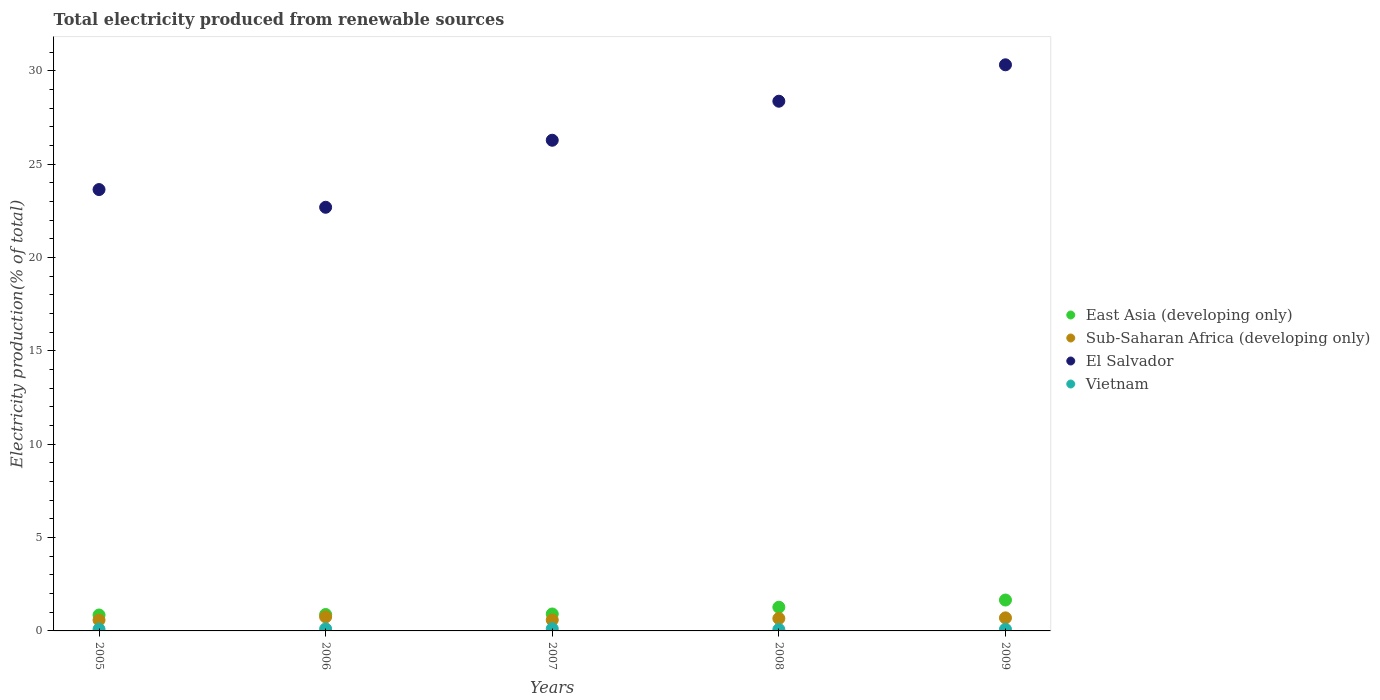How many different coloured dotlines are there?
Ensure brevity in your answer.  4. Is the number of dotlines equal to the number of legend labels?
Offer a terse response. Yes. What is the total electricity produced in East Asia (developing only) in 2008?
Provide a succinct answer. 1.27. Across all years, what is the maximum total electricity produced in East Asia (developing only)?
Make the answer very short. 1.65. Across all years, what is the minimum total electricity produced in Sub-Saharan Africa (developing only)?
Make the answer very short. 0.58. In which year was the total electricity produced in Sub-Saharan Africa (developing only) maximum?
Provide a short and direct response. 2006. What is the total total electricity produced in East Asia (developing only) in the graph?
Offer a terse response. 5.56. What is the difference between the total electricity produced in Sub-Saharan Africa (developing only) in 2007 and that in 2008?
Your response must be concise. -0.08. What is the difference between the total electricity produced in El Salvador in 2006 and the total electricity produced in East Asia (developing only) in 2007?
Your answer should be compact. 21.78. What is the average total electricity produced in Sub-Saharan Africa (developing only) per year?
Give a very brief answer. 0.66. In the year 2005, what is the difference between the total electricity produced in East Asia (developing only) and total electricity produced in Sub-Saharan Africa (developing only)?
Give a very brief answer. 0.27. What is the ratio of the total electricity produced in El Salvador in 2005 to that in 2009?
Make the answer very short. 0.78. Is the total electricity produced in Sub-Saharan Africa (developing only) in 2005 less than that in 2008?
Offer a terse response. Yes. What is the difference between the highest and the second highest total electricity produced in Sub-Saharan Africa (developing only)?
Your answer should be compact. 0.05. What is the difference between the highest and the lowest total electricity produced in Vietnam?
Provide a short and direct response. 0.04. Is it the case that in every year, the sum of the total electricity produced in East Asia (developing only) and total electricity produced in Sub-Saharan Africa (developing only)  is greater than the sum of total electricity produced in El Salvador and total electricity produced in Vietnam?
Provide a succinct answer. Yes. Is it the case that in every year, the sum of the total electricity produced in Sub-Saharan Africa (developing only) and total electricity produced in East Asia (developing only)  is greater than the total electricity produced in Vietnam?
Your answer should be compact. Yes. Does the total electricity produced in El Salvador monotonically increase over the years?
Provide a short and direct response. No. Is the total electricity produced in Vietnam strictly greater than the total electricity produced in El Salvador over the years?
Provide a short and direct response. No. Is the total electricity produced in East Asia (developing only) strictly less than the total electricity produced in Sub-Saharan Africa (developing only) over the years?
Give a very brief answer. No. How many dotlines are there?
Ensure brevity in your answer.  4. What is the difference between two consecutive major ticks on the Y-axis?
Your response must be concise. 5. Are the values on the major ticks of Y-axis written in scientific E-notation?
Keep it short and to the point. No. Does the graph contain grids?
Your response must be concise. No. What is the title of the graph?
Ensure brevity in your answer.  Total electricity produced from renewable sources. Does "High income" appear as one of the legend labels in the graph?
Your answer should be compact. No. What is the label or title of the Y-axis?
Provide a succinct answer. Electricity production(% of total). What is the Electricity production(% of total) in East Asia (developing only) in 2005?
Make the answer very short. 0.85. What is the Electricity production(% of total) in Sub-Saharan Africa (developing only) in 2005?
Ensure brevity in your answer.  0.58. What is the Electricity production(% of total) in El Salvador in 2005?
Your response must be concise. 23.64. What is the Electricity production(% of total) of Vietnam in 2005?
Give a very brief answer. 0.09. What is the Electricity production(% of total) in East Asia (developing only) in 2006?
Keep it short and to the point. 0.88. What is the Electricity production(% of total) of Sub-Saharan Africa (developing only) in 2006?
Your response must be concise. 0.75. What is the Electricity production(% of total) of El Salvador in 2006?
Provide a short and direct response. 22.69. What is the Electricity production(% of total) in Vietnam in 2006?
Make the answer very short. 0.11. What is the Electricity production(% of total) in East Asia (developing only) in 2007?
Make the answer very short. 0.91. What is the Electricity production(% of total) in Sub-Saharan Africa (developing only) in 2007?
Provide a short and direct response. 0.59. What is the Electricity production(% of total) in El Salvador in 2007?
Offer a very short reply. 26.28. What is the Electricity production(% of total) in Vietnam in 2007?
Offer a very short reply. 0.12. What is the Electricity production(% of total) in East Asia (developing only) in 2008?
Your answer should be compact. 1.27. What is the Electricity production(% of total) of Sub-Saharan Africa (developing only) in 2008?
Your answer should be compact. 0.67. What is the Electricity production(% of total) of El Salvador in 2008?
Make the answer very short. 28.37. What is the Electricity production(% of total) of Vietnam in 2008?
Ensure brevity in your answer.  0.08. What is the Electricity production(% of total) of East Asia (developing only) in 2009?
Offer a terse response. 1.65. What is the Electricity production(% of total) of Sub-Saharan Africa (developing only) in 2009?
Make the answer very short. 0.7. What is the Electricity production(% of total) of El Salvador in 2009?
Your answer should be compact. 30.32. What is the Electricity production(% of total) of Vietnam in 2009?
Offer a very short reply. 0.09. Across all years, what is the maximum Electricity production(% of total) of East Asia (developing only)?
Offer a terse response. 1.65. Across all years, what is the maximum Electricity production(% of total) of Sub-Saharan Africa (developing only)?
Keep it short and to the point. 0.75. Across all years, what is the maximum Electricity production(% of total) of El Salvador?
Make the answer very short. 30.32. Across all years, what is the maximum Electricity production(% of total) in Vietnam?
Offer a very short reply. 0.12. Across all years, what is the minimum Electricity production(% of total) of East Asia (developing only)?
Your answer should be compact. 0.85. Across all years, what is the minimum Electricity production(% of total) in Sub-Saharan Africa (developing only)?
Keep it short and to the point. 0.58. Across all years, what is the minimum Electricity production(% of total) in El Salvador?
Your answer should be compact. 22.69. Across all years, what is the minimum Electricity production(% of total) in Vietnam?
Offer a terse response. 0.08. What is the total Electricity production(% of total) of East Asia (developing only) in the graph?
Offer a very short reply. 5.56. What is the total Electricity production(% of total) of Sub-Saharan Africa (developing only) in the graph?
Offer a very short reply. 3.29. What is the total Electricity production(% of total) in El Salvador in the graph?
Provide a short and direct response. 131.29. What is the total Electricity production(% of total) of Vietnam in the graph?
Provide a succinct answer. 0.48. What is the difference between the Electricity production(% of total) in East Asia (developing only) in 2005 and that in 2006?
Keep it short and to the point. -0.03. What is the difference between the Electricity production(% of total) of Sub-Saharan Africa (developing only) in 2005 and that in 2006?
Offer a terse response. -0.17. What is the difference between the Electricity production(% of total) of El Salvador in 2005 and that in 2006?
Ensure brevity in your answer.  0.95. What is the difference between the Electricity production(% of total) in Vietnam in 2005 and that in 2006?
Your response must be concise. -0.01. What is the difference between the Electricity production(% of total) in East Asia (developing only) in 2005 and that in 2007?
Make the answer very short. -0.06. What is the difference between the Electricity production(% of total) of Sub-Saharan Africa (developing only) in 2005 and that in 2007?
Your response must be concise. -0.01. What is the difference between the Electricity production(% of total) in El Salvador in 2005 and that in 2007?
Offer a very short reply. -2.64. What is the difference between the Electricity production(% of total) in Vietnam in 2005 and that in 2007?
Your response must be concise. -0.02. What is the difference between the Electricity production(% of total) of East Asia (developing only) in 2005 and that in 2008?
Ensure brevity in your answer.  -0.42. What is the difference between the Electricity production(% of total) in Sub-Saharan Africa (developing only) in 2005 and that in 2008?
Give a very brief answer. -0.09. What is the difference between the Electricity production(% of total) in El Salvador in 2005 and that in 2008?
Give a very brief answer. -4.73. What is the difference between the Electricity production(% of total) in Vietnam in 2005 and that in 2008?
Provide a succinct answer. 0.02. What is the difference between the Electricity production(% of total) in East Asia (developing only) in 2005 and that in 2009?
Give a very brief answer. -0.8. What is the difference between the Electricity production(% of total) in Sub-Saharan Africa (developing only) in 2005 and that in 2009?
Keep it short and to the point. -0.12. What is the difference between the Electricity production(% of total) in El Salvador in 2005 and that in 2009?
Offer a very short reply. -6.68. What is the difference between the Electricity production(% of total) of Vietnam in 2005 and that in 2009?
Keep it short and to the point. 0.01. What is the difference between the Electricity production(% of total) of East Asia (developing only) in 2006 and that in 2007?
Offer a very short reply. -0.03. What is the difference between the Electricity production(% of total) in Sub-Saharan Africa (developing only) in 2006 and that in 2007?
Offer a very short reply. 0.16. What is the difference between the Electricity production(% of total) of El Salvador in 2006 and that in 2007?
Give a very brief answer. -3.59. What is the difference between the Electricity production(% of total) in Vietnam in 2006 and that in 2007?
Ensure brevity in your answer.  -0.01. What is the difference between the Electricity production(% of total) of East Asia (developing only) in 2006 and that in 2008?
Make the answer very short. -0.39. What is the difference between the Electricity production(% of total) in Sub-Saharan Africa (developing only) in 2006 and that in 2008?
Keep it short and to the point. 0.09. What is the difference between the Electricity production(% of total) of El Salvador in 2006 and that in 2008?
Make the answer very short. -5.68. What is the difference between the Electricity production(% of total) in Vietnam in 2006 and that in 2008?
Your answer should be compact. 0.03. What is the difference between the Electricity production(% of total) of East Asia (developing only) in 2006 and that in 2009?
Provide a short and direct response. -0.78. What is the difference between the Electricity production(% of total) of Sub-Saharan Africa (developing only) in 2006 and that in 2009?
Offer a very short reply. 0.05. What is the difference between the Electricity production(% of total) of El Salvador in 2006 and that in 2009?
Ensure brevity in your answer.  -7.63. What is the difference between the Electricity production(% of total) in Vietnam in 2006 and that in 2009?
Provide a short and direct response. 0.02. What is the difference between the Electricity production(% of total) of East Asia (developing only) in 2007 and that in 2008?
Give a very brief answer. -0.36. What is the difference between the Electricity production(% of total) in Sub-Saharan Africa (developing only) in 2007 and that in 2008?
Provide a succinct answer. -0.08. What is the difference between the Electricity production(% of total) in El Salvador in 2007 and that in 2008?
Ensure brevity in your answer.  -2.09. What is the difference between the Electricity production(% of total) of Vietnam in 2007 and that in 2008?
Ensure brevity in your answer.  0.04. What is the difference between the Electricity production(% of total) in East Asia (developing only) in 2007 and that in 2009?
Offer a very short reply. -0.75. What is the difference between the Electricity production(% of total) in Sub-Saharan Africa (developing only) in 2007 and that in 2009?
Offer a terse response. -0.11. What is the difference between the Electricity production(% of total) in El Salvador in 2007 and that in 2009?
Your answer should be compact. -4.04. What is the difference between the Electricity production(% of total) of Vietnam in 2007 and that in 2009?
Give a very brief answer. 0.03. What is the difference between the Electricity production(% of total) of East Asia (developing only) in 2008 and that in 2009?
Provide a succinct answer. -0.38. What is the difference between the Electricity production(% of total) of Sub-Saharan Africa (developing only) in 2008 and that in 2009?
Make the answer very short. -0.03. What is the difference between the Electricity production(% of total) of El Salvador in 2008 and that in 2009?
Provide a short and direct response. -1.95. What is the difference between the Electricity production(% of total) in Vietnam in 2008 and that in 2009?
Ensure brevity in your answer.  -0.01. What is the difference between the Electricity production(% of total) in East Asia (developing only) in 2005 and the Electricity production(% of total) in Sub-Saharan Africa (developing only) in 2006?
Make the answer very short. 0.1. What is the difference between the Electricity production(% of total) of East Asia (developing only) in 2005 and the Electricity production(% of total) of El Salvador in 2006?
Provide a succinct answer. -21.84. What is the difference between the Electricity production(% of total) of East Asia (developing only) in 2005 and the Electricity production(% of total) of Vietnam in 2006?
Provide a short and direct response. 0.74. What is the difference between the Electricity production(% of total) of Sub-Saharan Africa (developing only) in 2005 and the Electricity production(% of total) of El Salvador in 2006?
Keep it short and to the point. -22.11. What is the difference between the Electricity production(% of total) in Sub-Saharan Africa (developing only) in 2005 and the Electricity production(% of total) in Vietnam in 2006?
Your response must be concise. 0.47. What is the difference between the Electricity production(% of total) in El Salvador in 2005 and the Electricity production(% of total) in Vietnam in 2006?
Provide a succinct answer. 23.53. What is the difference between the Electricity production(% of total) of East Asia (developing only) in 2005 and the Electricity production(% of total) of Sub-Saharan Africa (developing only) in 2007?
Make the answer very short. 0.26. What is the difference between the Electricity production(% of total) of East Asia (developing only) in 2005 and the Electricity production(% of total) of El Salvador in 2007?
Ensure brevity in your answer.  -25.43. What is the difference between the Electricity production(% of total) in East Asia (developing only) in 2005 and the Electricity production(% of total) in Vietnam in 2007?
Offer a very short reply. 0.73. What is the difference between the Electricity production(% of total) of Sub-Saharan Africa (developing only) in 2005 and the Electricity production(% of total) of El Salvador in 2007?
Your answer should be compact. -25.7. What is the difference between the Electricity production(% of total) of Sub-Saharan Africa (developing only) in 2005 and the Electricity production(% of total) of Vietnam in 2007?
Provide a succinct answer. 0.46. What is the difference between the Electricity production(% of total) in El Salvador in 2005 and the Electricity production(% of total) in Vietnam in 2007?
Your response must be concise. 23.52. What is the difference between the Electricity production(% of total) of East Asia (developing only) in 2005 and the Electricity production(% of total) of Sub-Saharan Africa (developing only) in 2008?
Offer a terse response. 0.19. What is the difference between the Electricity production(% of total) of East Asia (developing only) in 2005 and the Electricity production(% of total) of El Salvador in 2008?
Your response must be concise. -27.52. What is the difference between the Electricity production(% of total) of East Asia (developing only) in 2005 and the Electricity production(% of total) of Vietnam in 2008?
Your answer should be very brief. 0.78. What is the difference between the Electricity production(% of total) of Sub-Saharan Africa (developing only) in 2005 and the Electricity production(% of total) of El Salvador in 2008?
Provide a succinct answer. -27.79. What is the difference between the Electricity production(% of total) of Sub-Saharan Africa (developing only) in 2005 and the Electricity production(% of total) of Vietnam in 2008?
Make the answer very short. 0.5. What is the difference between the Electricity production(% of total) in El Salvador in 2005 and the Electricity production(% of total) in Vietnam in 2008?
Ensure brevity in your answer.  23.56. What is the difference between the Electricity production(% of total) in East Asia (developing only) in 2005 and the Electricity production(% of total) in Sub-Saharan Africa (developing only) in 2009?
Your answer should be very brief. 0.15. What is the difference between the Electricity production(% of total) in East Asia (developing only) in 2005 and the Electricity production(% of total) in El Salvador in 2009?
Make the answer very short. -29.47. What is the difference between the Electricity production(% of total) in East Asia (developing only) in 2005 and the Electricity production(% of total) in Vietnam in 2009?
Your answer should be compact. 0.77. What is the difference between the Electricity production(% of total) in Sub-Saharan Africa (developing only) in 2005 and the Electricity production(% of total) in El Salvador in 2009?
Your response must be concise. -29.74. What is the difference between the Electricity production(% of total) of Sub-Saharan Africa (developing only) in 2005 and the Electricity production(% of total) of Vietnam in 2009?
Your answer should be compact. 0.49. What is the difference between the Electricity production(% of total) in El Salvador in 2005 and the Electricity production(% of total) in Vietnam in 2009?
Ensure brevity in your answer.  23.55. What is the difference between the Electricity production(% of total) of East Asia (developing only) in 2006 and the Electricity production(% of total) of Sub-Saharan Africa (developing only) in 2007?
Provide a succinct answer. 0.29. What is the difference between the Electricity production(% of total) of East Asia (developing only) in 2006 and the Electricity production(% of total) of El Salvador in 2007?
Offer a very short reply. -25.4. What is the difference between the Electricity production(% of total) in East Asia (developing only) in 2006 and the Electricity production(% of total) in Vietnam in 2007?
Your answer should be compact. 0.76. What is the difference between the Electricity production(% of total) in Sub-Saharan Africa (developing only) in 2006 and the Electricity production(% of total) in El Salvador in 2007?
Give a very brief answer. -25.53. What is the difference between the Electricity production(% of total) of Sub-Saharan Africa (developing only) in 2006 and the Electricity production(% of total) of Vietnam in 2007?
Keep it short and to the point. 0.63. What is the difference between the Electricity production(% of total) in El Salvador in 2006 and the Electricity production(% of total) in Vietnam in 2007?
Offer a very short reply. 22.57. What is the difference between the Electricity production(% of total) of East Asia (developing only) in 2006 and the Electricity production(% of total) of Sub-Saharan Africa (developing only) in 2008?
Make the answer very short. 0.21. What is the difference between the Electricity production(% of total) in East Asia (developing only) in 2006 and the Electricity production(% of total) in El Salvador in 2008?
Your response must be concise. -27.49. What is the difference between the Electricity production(% of total) in East Asia (developing only) in 2006 and the Electricity production(% of total) in Vietnam in 2008?
Give a very brief answer. 0.8. What is the difference between the Electricity production(% of total) in Sub-Saharan Africa (developing only) in 2006 and the Electricity production(% of total) in El Salvador in 2008?
Provide a succinct answer. -27.62. What is the difference between the Electricity production(% of total) of Sub-Saharan Africa (developing only) in 2006 and the Electricity production(% of total) of Vietnam in 2008?
Your response must be concise. 0.68. What is the difference between the Electricity production(% of total) of El Salvador in 2006 and the Electricity production(% of total) of Vietnam in 2008?
Offer a very short reply. 22.61. What is the difference between the Electricity production(% of total) in East Asia (developing only) in 2006 and the Electricity production(% of total) in Sub-Saharan Africa (developing only) in 2009?
Make the answer very short. 0.18. What is the difference between the Electricity production(% of total) of East Asia (developing only) in 2006 and the Electricity production(% of total) of El Salvador in 2009?
Keep it short and to the point. -29.44. What is the difference between the Electricity production(% of total) in East Asia (developing only) in 2006 and the Electricity production(% of total) in Vietnam in 2009?
Keep it short and to the point. 0.79. What is the difference between the Electricity production(% of total) of Sub-Saharan Africa (developing only) in 2006 and the Electricity production(% of total) of El Salvador in 2009?
Ensure brevity in your answer.  -29.57. What is the difference between the Electricity production(% of total) in Sub-Saharan Africa (developing only) in 2006 and the Electricity production(% of total) in Vietnam in 2009?
Offer a terse response. 0.67. What is the difference between the Electricity production(% of total) of El Salvador in 2006 and the Electricity production(% of total) of Vietnam in 2009?
Provide a short and direct response. 22.6. What is the difference between the Electricity production(% of total) of East Asia (developing only) in 2007 and the Electricity production(% of total) of Sub-Saharan Africa (developing only) in 2008?
Your response must be concise. 0.24. What is the difference between the Electricity production(% of total) in East Asia (developing only) in 2007 and the Electricity production(% of total) in El Salvador in 2008?
Provide a short and direct response. -27.46. What is the difference between the Electricity production(% of total) of East Asia (developing only) in 2007 and the Electricity production(% of total) of Vietnam in 2008?
Your answer should be compact. 0.83. What is the difference between the Electricity production(% of total) of Sub-Saharan Africa (developing only) in 2007 and the Electricity production(% of total) of El Salvador in 2008?
Give a very brief answer. -27.78. What is the difference between the Electricity production(% of total) in Sub-Saharan Africa (developing only) in 2007 and the Electricity production(% of total) in Vietnam in 2008?
Ensure brevity in your answer.  0.51. What is the difference between the Electricity production(% of total) in El Salvador in 2007 and the Electricity production(% of total) in Vietnam in 2008?
Offer a very short reply. 26.2. What is the difference between the Electricity production(% of total) of East Asia (developing only) in 2007 and the Electricity production(% of total) of Sub-Saharan Africa (developing only) in 2009?
Provide a short and direct response. 0.21. What is the difference between the Electricity production(% of total) in East Asia (developing only) in 2007 and the Electricity production(% of total) in El Salvador in 2009?
Your response must be concise. -29.41. What is the difference between the Electricity production(% of total) in East Asia (developing only) in 2007 and the Electricity production(% of total) in Vietnam in 2009?
Your response must be concise. 0.82. What is the difference between the Electricity production(% of total) of Sub-Saharan Africa (developing only) in 2007 and the Electricity production(% of total) of El Salvador in 2009?
Offer a very short reply. -29.73. What is the difference between the Electricity production(% of total) in Sub-Saharan Africa (developing only) in 2007 and the Electricity production(% of total) in Vietnam in 2009?
Your response must be concise. 0.5. What is the difference between the Electricity production(% of total) in El Salvador in 2007 and the Electricity production(% of total) in Vietnam in 2009?
Make the answer very short. 26.19. What is the difference between the Electricity production(% of total) in East Asia (developing only) in 2008 and the Electricity production(% of total) in Sub-Saharan Africa (developing only) in 2009?
Provide a succinct answer. 0.57. What is the difference between the Electricity production(% of total) in East Asia (developing only) in 2008 and the Electricity production(% of total) in El Salvador in 2009?
Provide a short and direct response. -29.05. What is the difference between the Electricity production(% of total) in East Asia (developing only) in 2008 and the Electricity production(% of total) in Vietnam in 2009?
Your answer should be compact. 1.18. What is the difference between the Electricity production(% of total) of Sub-Saharan Africa (developing only) in 2008 and the Electricity production(% of total) of El Salvador in 2009?
Provide a succinct answer. -29.65. What is the difference between the Electricity production(% of total) of Sub-Saharan Africa (developing only) in 2008 and the Electricity production(% of total) of Vietnam in 2009?
Make the answer very short. 0.58. What is the difference between the Electricity production(% of total) of El Salvador in 2008 and the Electricity production(% of total) of Vietnam in 2009?
Provide a short and direct response. 28.28. What is the average Electricity production(% of total) in East Asia (developing only) per year?
Offer a terse response. 1.11. What is the average Electricity production(% of total) in Sub-Saharan Africa (developing only) per year?
Your answer should be very brief. 0.66. What is the average Electricity production(% of total) in El Salvador per year?
Provide a succinct answer. 26.26. What is the average Electricity production(% of total) in Vietnam per year?
Your answer should be compact. 0.1. In the year 2005, what is the difference between the Electricity production(% of total) of East Asia (developing only) and Electricity production(% of total) of Sub-Saharan Africa (developing only)?
Your answer should be very brief. 0.27. In the year 2005, what is the difference between the Electricity production(% of total) of East Asia (developing only) and Electricity production(% of total) of El Salvador?
Ensure brevity in your answer.  -22.78. In the year 2005, what is the difference between the Electricity production(% of total) in East Asia (developing only) and Electricity production(% of total) in Vietnam?
Provide a short and direct response. 0.76. In the year 2005, what is the difference between the Electricity production(% of total) of Sub-Saharan Africa (developing only) and Electricity production(% of total) of El Salvador?
Keep it short and to the point. -23.06. In the year 2005, what is the difference between the Electricity production(% of total) of Sub-Saharan Africa (developing only) and Electricity production(% of total) of Vietnam?
Keep it short and to the point. 0.49. In the year 2005, what is the difference between the Electricity production(% of total) of El Salvador and Electricity production(% of total) of Vietnam?
Ensure brevity in your answer.  23.54. In the year 2006, what is the difference between the Electricity production(% of total) in East Asia (developing only) and Electricity production(% of total) in Sub-Saharan Africa (developing only)?
Provide a succinct answer. 0.13. In the year 2006, what is the difference between the Electricity production(% of total) of East Asia (developing only) and Electricity production(% of total) of El Salvador?
Provide a short and direct response. -21.81. In the year 2006, what is the difference between the Electricity production(% of total) in East Asia (developing only) and Electricity production(% of total) in Vietnam?
Provide a short and direct response. 0.77. In the year 2006, what is the difference between the Electricity production(% of total) in Sub-Saharan Africa (developing only) and Electricity production(% of total) in El Salvador?
Offer a terse response. -21.94. In the year 2006, what is the difference between the Electricity production(% of total) in Sub-Saharan Africa (developing only) and Electricity production(% of total) in Vietnam?
Provide a succinct answer. 0.64. In the year 2006, what is the difference between the Electricity production(% of total) in El Salvador and Electricity production(% of total) in Vietnam?
Provide a succinct answer. 22.58. In the year 2007, what is the difference between the Electricity production(% of total) in East Asia (developing only) and Electricity production(% of total) in Sub-Saharan Africa (developing only)?
Give a very brief answer. 0.32. In the year 2007, what is the difference between the Electricity production(% of total) of East Asia (developing only) and Electricity production(% of total) of El Salvador?
Provide a succinct answer. -25.37. In the year 2007, what is the difference between the Electricity production(% of total) of East Asia (developing only) and Electricity production(% of total) of Vietnam?
Your answer should be very brief. 0.79. In the year 2007, what is the difference between the Electricity production(% of total) in Sub-Saharan Africa (developing only) and Electricity production(% of total) in El Salvador?
Your answer should be compact. -25.69. In the year 2007, what is the difference between the Electricity production(% of total) of Sub-Saharan Africa (developing only) and Electricity production(% of total) of Vietnam?
Your answer should be very brief. 0.47. In the year 2007, what is the difference between the Electricity production(% of total) of El Salvador and Electricity production(% of total) of Vietnam?
Your answer should be very brief. 26.16. In the year 2008, what is the difference between the Electricity production(% of total) of East Asia (developing only) and Electricity production(% of total) of Sub-Saharan Africa (developing only)?
Ensure brevity in your answer.  0.6. In the year 2008, what is the difference between the Electricity production(% of total) in East Asia (developing only) and Electricity production(% of total) in El Salvador?
Make the answer very short. -27.1. In the year 2008, what is the difference between the Electricity production(% of total) in East Asia (developing only) and Electricity production(% of total) in Vietnam?
Offer a terse response. 1.19. In the year 2008, what is the difference between the Electricity production(% of total) in Sub-Saharan Africa (developing only) and Electricity production(% of total) in El Salvador?
Make the answer very short. -27.7. In the year 2008, what is the difference between the Electricity production(% of total) in Sub-Saharan Africa (developing only) and Electricity production(% of total) in Vietnam?
Make the answer very short. 0.59. In the year 2008, what is the difference between the Electricity production(% of total) in El Salvador and Electricity production(% of total) in Vietnam?
Give a very brief answer. 28.29. In the year 2009, what is the difference between the Electricity production(% of total) of East Asia (developing only) and Electricity production(% of total) of Sub-Saharan Africa (developing only)?
Your answer should be very brief. 0.96. In the year 2009, what is the difference between the Electricity production(% of total) in East Asia (developing only) and Electricity production(% of total) in El Salvador?
Keep it short and to the point. -28.66. In the year 2009, what is the difference between the Electricity production(% of total) in East Asia (developing only) and Electricity production(% of total) in Vietnam?
Offer a terse response. 1.57. In the year 2009, what is the difference between the Electricity production(% of total) of Sub-Saharan Africa (developing only) and Electricity production(% of total) of El Salvador?
Make the answer very short. -29.62. In the year 2009, what is the difference between the Electricity production(% of total) of Sub-Saharan Africa (developing only) and Electricity production(% of total) of Vietnam?
Give a very brief answer. 0.61. In the year 2009, what is the difference between the Electricity production(% of total) of El Salvador and Electricity production(% of total) of Vietnam?
Your response must be concise. 30.23. What is the ratio of the Electricity production(% of total) of East Asia (developing only) in 2005 to that in 2006?
Make the answer very short. 0.97. What is the ratio of the Electricity production(% of total) in Sub-Saharan Africa (developing only) in 2005 to that in 2006?
Provide a short and direct response. 0.77. What is the ratio of the Electricity production(% of total) in El Salvador in 2005 to that in 2006?
Keep it short and to the point. 1.04. What is the ratio of the Electricity production(% of total) of Vietnam in 2005 to that in 2006?
Provide a succinct answer. 0.87. What is the ratio of the Electricity production(% of total) of East Asia (developing only) in 2005 to that in 2007?
Ensure brevity in your answer.  0.94. What is the ratio of the Electricity production(% of total) of El Salvador in 2005 to that in 2007?
Ensure brevity in your answer.  0.9. What is the ratio of the Electricity production(% of total) of Vietnam in 2005 to that in 2007?
Offer a terse response. 0.79. What is the ratio of the Electricity production(% of total) of East Asia (developing only) in 2005 to that in 2008?
Give a very brief answer. 0.67. What is the ratio of the Electricity production(% of total) in Sub-Saharan Africa (developing only) in 2005 to that in 2008?
Keep it short and to the point. 0.87. What is the ratio of the Electricity production(% of total) in El Salvador in 2005 to that in 2008?
Give a very brief answer. 0.83. What is the ratio of the Electricity production(% of total) of Vietnam in 2005 to that in 2008?
Your answer should be compact. 1.22. What is the ratio of the Electricity production(% of total) of East Asia (developing only) in 2005 to that in 2009?
Ensure brevity in your answer.  0.52. What is the ratio of the Electricity production(% of total) of Sub-Saharan Africa (developing only) in 2005 to that in 2009?
Your response must be concise. 0.83. What is the ratio of the Electricity production(% of total) in El Salvador in 2005 to that in 2009?
Give a very brief answer. 0.78. What is the ratio of the Electricity production(% of total) in Vietnam in 2005 to that in 2009?
Your response must be concise. 1.08. What is the ratio of the Electricity production(% of total) in East Asia (developing only) in 2006 to that in 2007?
Offer a terse response. 0.97. What is the ratio of the Electricity production(% of total) of Sub-Saharan Africa (developing only) in 2006 to that in 2007?
Offer a terse response. 1.28. What is the ratio of the Electricity production(% of total) in El Salvador in 2006 to that in 2007?
Make the answer very short. 0.86. What is the ratio of the Electricity production(% of total) of Vietnam in 2006 to that in 2007?
Offer a very short reply. 0.91. What is the ratio of the Electricity production(% of total) of East Asia (developing only) in 2006 to that in 2008?
Offer a terse response. 0.69. What is the ratio of the Electricity production(% of total) in Sub-Saharan Africa (developing only) in 2006 to that in 2008?
Your answer should be very brief. 1.13. What is the ratio of the Electricity production(% of total) in El Salvador in 2006 to that in 2008?
Provide a short and direct response. 0.8. What is the ratio of the Electricity production(% of total) in Vietnam in 2006 to that in 2008?
Keep it short and to the point. 1.41. What is the ratio of the Electricity production(% of total) of East Asia (developing only) in 2006 to that in 2009?
Offer a very short reply. 0.53. What is the ratio of the Electricity production(% of total) in Sub-Saharan Africa (developing only) in 2006 to that in 2009?
Provide a succinct answer. 1.08. What is the ratio of the Electricity production(% of total) in El Salvador in 2006 to that in 2009?
Provide a succinct answer. 0.75. What is the ratio of the Electricity production(% of total) of Vietnam in 2006 to that in 2009?
Make the answer very short. 1.24. What is the ratio of the Electricity production(% of total) of East Asia (developing only) in 2007 to that in 2008?
Make the answer very short. 0.71. What is the ratio of the Electricity production(% of total) in Sub-Saharan Africa (developing only) in 2007 to that in 2008?
Ensure brevity in your answer.  0.88. What is the ratio of the Electricity production(% of total) of El Salvador in 2007 to that in 2008?
Ensure brevity in your answer.  0.93. What is the ratio of the Electricity production(% of total) in Vietnam in 2007 to that in 2008?
Your answer should be compact. 1.55. What is the ratio of the Electricity production(% of total) in East Asia (developing only) in 2007 to that in 2009?
Offer a terse response. 0.55. What is the ratio of the Electricity production(% of total) in Sub-Saharan Africa (developing only) in 2007 to that in 2009?
Provide a succinct answer. 0.84. What is the ratio of the Electricity production(% of total) of El Salvador in 2007 to that in 2009?
Provide a short and direct response. 0.87. What is the ratio of the Electricity production(% of total) in Vietnam in 2007 to that in 2009?
Your response must be concise. 1.36. What is the ratio of the Electricity production(% of total) of East Asia (developing only) in 2008 to that in 2009?
Ensure brevity in your answer.  0.77. What is the ratio of the Electricity production(% of total) of Sub-Saharan Africa (developing only) in 2008 to that in 2009?
Provide a short and direct response. 0.95. What is the ratio of the Electricity production(% of total) of El Salvador in 2008 to that in 2009?
Ensure brevity in your answer.  0.94. What is the ratio of the Electricity production(% of total) in Vietnam in 2008 to that in 2009?
Provide a short and direct response. 0.88. What is the difference between the highest and the second highest Electricity production(% of total) in East Asia (developing only)?
Your answer should be very brief. 0.38. What is the difference between the highest and the second highest Electricity production(% of total) in Sub-Saharan Africa (developing only)?
Offer a very short reply. 0.05. What is the difference between the highest and the second highest Electricity production(% of total) in El Salvador?
Ensure brevity in your answer.  1.95. What is the difference between the highest and the second highest Electricity production(% of total) in Vietnam?
Your answer should be compact. 0.01. What is the difference between the highest and the lowest Electricity production(% of total) of East Asia (developing only)?
Your response must be concise. 0.8. What is the difference between the highest and the lowest Electricity production(% of total) of Sub-Saharan Africa (developing only)?
Make the answer very short. 0.17. What is the difference between the highest and the lowest Electricity production(% of total) of El Salvador?
Provide a succinct answer. 7.63. What is the difference between the highest and the lowest Electricity production(% of total) of Vietnam?
Make the answer very short. 0.04. 